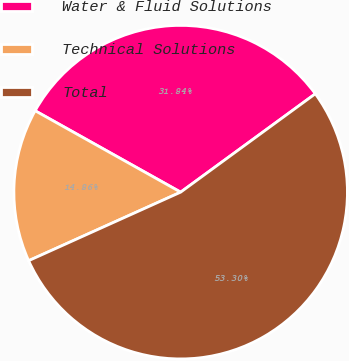Convert chart to OTSL. <chart><loc_0><loc_0><loc_500><loc_500><pie_chart><fcel>Water & Fluid Solutions<fcel>Technical Solutions<fcel>Total<nl><fcel>31.84%<fcel>14.86%<fcel>53.3%<nl></chart> 